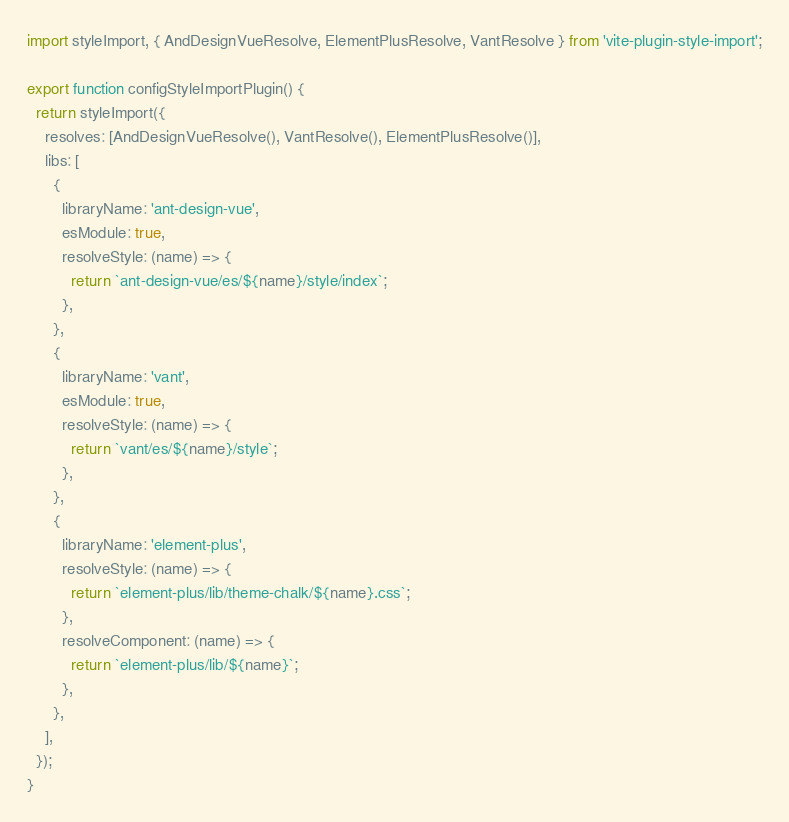Convert code to text. <code><loc_0><loc_0><loc_500><loc_500><_TypeScript_>import styleImport, { AndDesignVueResolve, ElementPlusResolve, VantResolve } from 'vite-plugin-style-import';

export function configStyleImportPlugin() {
  return styleImport({
    resolves: [AndDesignVueResolve(), VantResolve(), ElementPlusResolve()],
    libs: [
      {
        libraryName: 'ant-design-vue',
        esModule: true,
        resolveStyle: (name) => {
          return `ant-design-vue/es/${name}/style/index`;
        },
      },
      {
        libraryName: 'vant',
        esModule: true,
        resolveStyle: (name) => {
          return `vant/es/${name}/style`;
        },
      },
      {
        libraryName: 'element-plus',
        resolveStyle: (name) => {
          return `element-plus/lib/theme-chalk/${name}.css`;
        },
        resolveComponent: (name) => {
          return `element-plus/lib/${name}`;
        },
      },
    ],
  });
}
</code> 